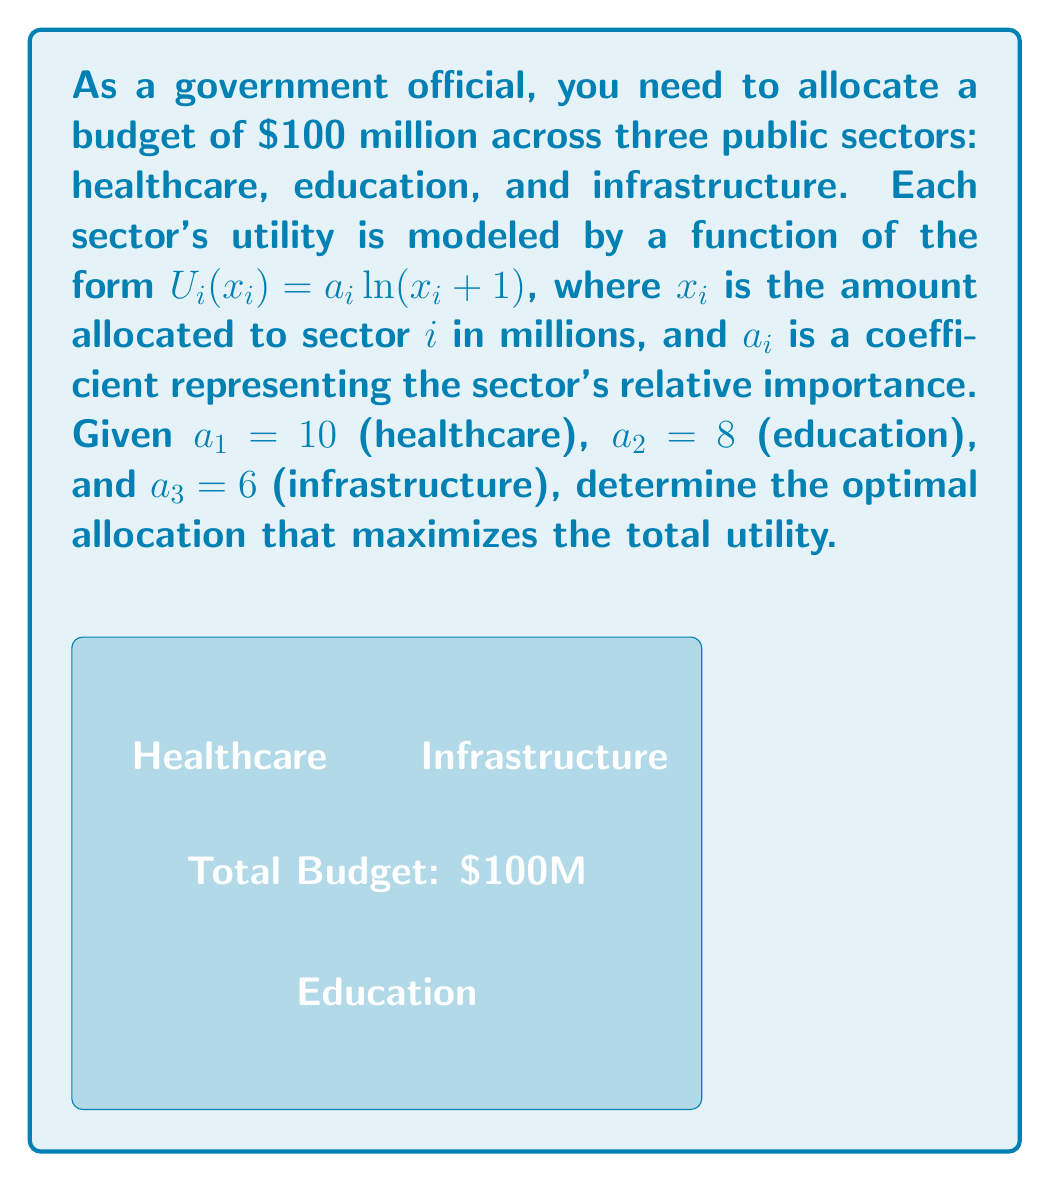Solve this math problem. To solve this problem, we'll use the method of Lagrange multipliers, which is ideal for optimizing constrained systems.

Step 1: Define the objective function and constraint.
Objective function: $U(x_1, x_2, x_3) = 10\ln(x_1 + 1) + 8\ln(x_2 + 1) + 6\ln(x_3 + 1)$
Constraint: $g(x_1, x_2, x_3) = x_1 + x_2 + x_3 - 100 = 0$

Step 2: Form the Lagrangian function.
$L(x_1, x_2, x_3, \lambda) = 10\ln(x_1 + 1) + 8\ln(x_2 + 1) + 6\ln(x_3 + 1) - \lambda(x_1 + x_2 + x_3 - 100)$

Step 3: Take partial derivatives and set them to zero.
$\frac{\partial L}{\partial x_1} = \frac{10}{x_1 + 1} - \lambda = 0$
$\frac{\partial L}{\partial x_2} = \frac{8}{x_2 + 1} - \lambda = 0$
$\frac{\partial L}{\partial x_3} = \frac{6}{x_3 + 1} - \lambda = 0$
$\frac{\partial L}{\partial \lambda} = x_1 + x_2 + x_3 - 100 = 0$

Step 4: Solve the system of equations.
From the first three equations:
$x_1 + 1 = \frac{10}{\lambda}$
$x_2 + 1 = \frac{8}{\lambda}$
$x_3 + 1 = \frac{6}{\lambda}$

Substituting into the constraint equation:
$(\frac{10}{\lambda} - 1) + (\frac{8}{\lambda} - 1) + (\frac{6}{\lambda} - 1) = 100$

Simplifying:
$\frac{24}{\lambda} - 3 = 100$
$\frac{24}{\lambda} = 103$
$\lambda = \frac{24}{103}$

Step 5: Calculate the optimal allocations.
$x_1 = \frac{10}{\lambda} - 1 = \frac{10 \cdot 103}{24} - 1 \approx 41.92$
$x_2 = \frac{8}{\lambda} - 1 = \frac{8 \cdot 103}{24} - 1 \approx 33.33$
$x_3 = \frac{6}{\lambda} - 1 = \frac{6 \cdot 103}{24} - 1 \approx 24.75$

Step 6: Verify the sum equals 100.
$41.92 + 33.33 + 24.75 = 100$

Therefore, the optimal allocation is approximately:
Healthcare: $41.92 million
Education: $33.33 million
Infrastructure: $24.75 million
Answer: Healthcare: $41.92M, Education: $33.33M, Infrastructure: $24.75M 